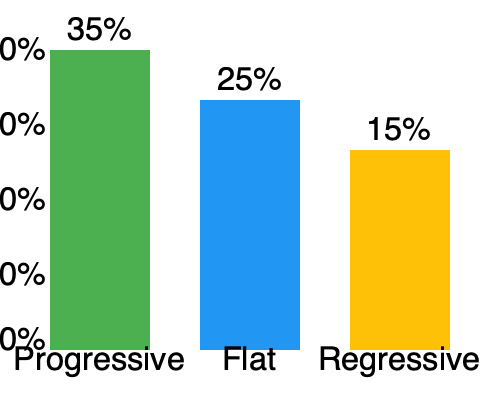Based on the bar chart comparing different tax structures, which system would likely be most effective in addressing income inequality while potentially causing the least economic disruption? To answer this question, we need to consider the characteristics of each tax structure and their potential impacts on income inequality and economic activity:

1. Progressive tax:
   - Highest bar (35% tax rate)
   - Tax rate increases as income increases
   - Reduces income inequality by taxing higher earners at a higher rate
   - May discourage some high-income economic activity

2. Flat tax:
   - Middle bar (25% tax rate)
   - Same tax rate for all income levels
   - Neutral effect on income inequality
   - Simplifies tax system, potentially reducing compliance costs

3. Regressive tax:
   - Lowest bar (15% tax rate)
   - Tax rate decreases as income increases
   - Increases income inequality by taxing lower earners at a higher effective rate
   - May encourage high-income economic activity

Considering the goal of addressing inequality while minimizing economic disruption:

- The progressive tax is most effective at reducing inequality but may cause some economic disruption at higher income levels.
- The flat tax is neutral on inequality but may be the least disruptive economically due to its simplicity.
- The regressive tax would worsen inequality and is therefore not suitable for the stated goal.

The flat tax system represents a middle ground that could address inequality to some extent (by ensuring everyone pays the same rate) while potentially causing the least economic disruption due to its simplicity and uniform application across all income levels.
Answer: Flat tax system 